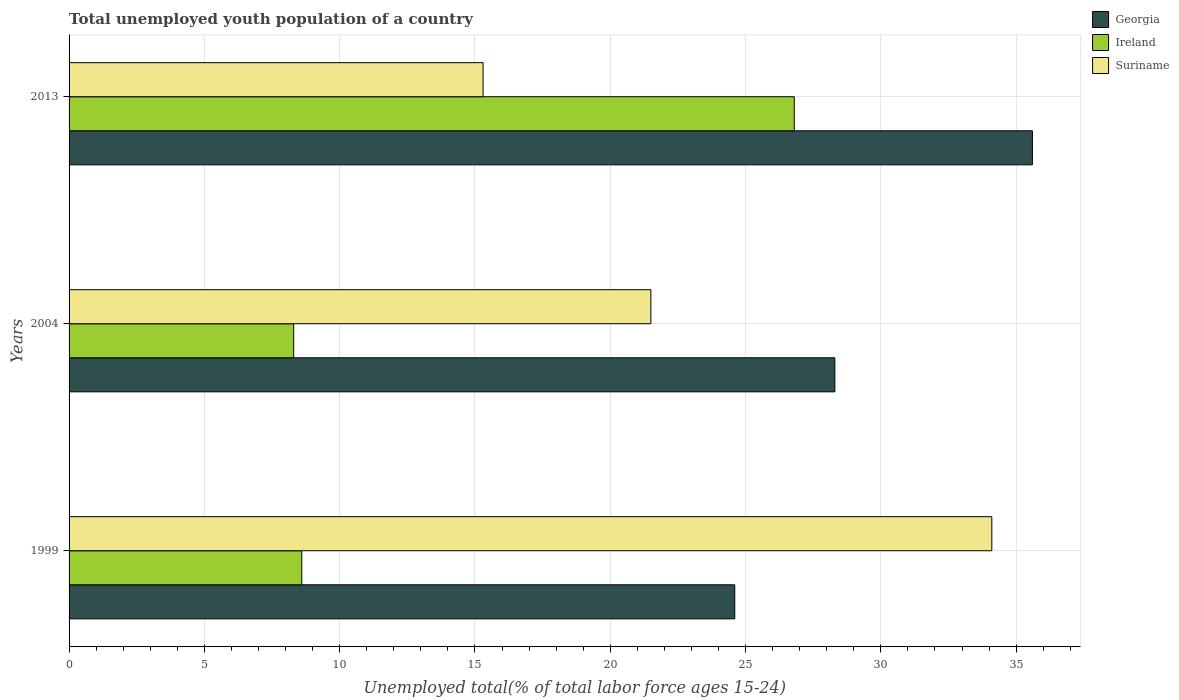How many different coloured bars are there?
Your response must be concise. 3. How many groups of bars are there?
Your response must be concise. 3. Are the number of bars per tick equal to the number of legend labels?
Give a very brief answer. Yes. Are the number of bars on each tick of the Y-axis equal?
Provide a short and direct response. Yes. What is the label of the 2nd group of bars from the top?
Offer a very short reply. 2004. Across all years, what is the maximum percentage of total unemployed youth population of a country in Ireland?
Make the answer very short. 26.8. Across all years, what is the minimum percentage of total unemployed youth population of a country in Suriname?
Your answer should be compact. 15.3. In which year was the percentage of total unemployed youth population of a country in Suriname maximum?
Keep it short and to the point. 1999. What is the total percentage of total unemployed youth population of a country in Suriname in the graph?
Your response must be concise. 70.9. What is the difference between the percentage of total unemployed youth population of a country in Ireland in 1999 and that in 2004?
Offer a terse response. 0.3. What is the difference between the percentage of total unemployed youth population of a country in Ireland in 2013 and the percentage of total unemployed youth population of a country in Suriname in 1999?
Your response must be concise. -7.3. What is the average percentage of total unemployed youth population of a country in Suriname per year?
Make the answer very short. 23.63. In the year 2013, what is the difference between the percentage of total unemployed youth population of a country in Ireland and percentage of total unemployed youth population of a country in Georgia?
Offer a terse response. -8.8. What is the ratio of the percentage of total unemployed youth population of a country in Georgia in 1999 to that in 2004?
Keep it short and to the point. 0.87. Is the percentage of total unemployed youth population of a country in Suriname in 1999 less than that in 2004?
Offer a terse response. No. Is the difference between the percentage of total unemployed youth population of a country in Ireland in 1999 and 2004 greater than the difference between the percentage of total unemployed youth population of a country in Georgia in 1999 and 2004?
Give a very brief answer. Yes. What is the difference between the highest and the second highest percentage of total unemployed youth population of a country in Suriname?
Make the answer very short. 12.6. What is the difference between the highest and the lowest percentage of total unemployed youth population of a country in Georgia?
Make the answer very short. 11. Is the sum of the percentage of total unemployed youth population of a country in Suriname in 1999 and 2013 greater than the maximum percentage of total unemployed youth population of a country in Ireland across all years?
Your answer should be compact. Yes. What does the 1st bar from the top in 1999 represents?
Keep it short and to the point. Suriname. What does the 1st bar from the bottom in 2013 represents?
Give a very brief answer. Georgia. Is it the case that in every year, the sum of the percentage of total unemployed youth population of a country in Georgia and percentage of total unemployed youth population of a country in Ireland is greater than the percentage of total unemployed youth population of a country in Suriname?
Make the answer very short. No. How many years are there in the graph?
Make the answer very short. 3. Are the values on the major ticks of X-axis written in scientific E-notation?
Make the answer very short. No. Where does the legend appear in the graph?
Your answer should be very brief. Top right. How are the legend labels stacked?
Keep it short and to the point. Vertical. What is the title of the graph?
Offer a terse response. Total unemployed youth population of a country. What is the label or title of the X-axis?
Give a very brief answer. Unemployed total(% of total labor force ages 15-24). What is the label or title of the Y-axis?
Provide a succinct answer. Years. What is the Unemployed total(% of total labor force ages 15-24) of Georgia in 1999?
Provide a succinct answer. 24.6. What is the Unemployed total(% of total labor force ages 15-24) in Ireland in 1999?
Provide a succinct answer. 8.6. What is the Unemployed total(% of total labor force ages 15-24) in Suriname in 1999?
Ensure brevity in your answer.  34.1. What is the Unemployed total(% of total labor force ages 15-24) in Georgia in 2004?
Offer a very short reply. 28.3. What is the Unemployed total(% of total labor force ages 15-24) in Ireland in 2004?
Ensure brevity in your answer.  8.3. What is the Unemployed total(% of total labor force ages 15-24) of Suriname in 2004?
Your answer should be compact. 21.5. What is the Unemployed total(% of total labor force ages 15-24) of Georgia in 2013?
Your answer should be very brief. 35.6. What is the Unemployed total(% of total labor force ages 15-24) in Ireland in 2013?
Your response must be concise. 26.8. What is the Unemployed total(% of total labor force ages 15-24) in Suriname in 2013?
Provide a short and direct response. 15.3. Across all years, what is the maximum Unemployed total(% of total labor force ages 15-24) of Georgia?
Provide a short and direct response. 35.6. Across all years, what is the maximum Unemployed total(% of total labor force ages 15-24) in Ireland?
Your answer should be compact. 26.8. Across all years, what is the maximum Unemployed total(% of total labor force ages 15-24) in Suriname?
Offer a terse response. 34.1. Across all years, what is the minimum Unemployed total(% of total labor force ages 15-24) in Georgia?
Ensure brevity in your answer.  24.6. Across all years, what is the minimum Unemployed total(% of total labor force ages 15-24) of Ireland?
Offer a very short reply. 8.3. Across all years, what is the minimum Unemployed total(% of total labor force ages 15-24) in Suriname?
Make the answer very short. 15.3. What is the total Unemployed total(% of total labor force ages 15-24) in Georgia in the graph?
Your answer should be compact. 88.5. What is the total Unemployed total(% of total labor force ages 15-24) in Ireland in the graph?
Provide a succinct answer. 43.7. What is the total Unemployed total(% of total labor force ages 15-24) in Suriname in the graph?
Offer a very short reply. 70.9. What is the difference between the Unemployed total(% of total labor force ages 15-24) of Georgia in 1999 and that in 2004?
Offer a very short reply. -3.7. What is the difference between the Unemployed total(% of total labor force ages 15-24) in Suriname in 1999 and that in 2004?
Make the answer very short. 12.6. What is the difference between the Unemployed total(% of total labor force ages 15-24) in Georgia in 1999 and that in 2013?
Keep it short and to the point. -11. What is the difference between the Unemployed total(% of total labor force ages 15-24) of Ireland in 1999 and that in 2013?
Offer a very short reply. -18.2. What is the difference between the Unemployed total(% of total labor force ages 15-24) of Georgia in 2004 and that in 2013?
Offer a terse response. -7.3. What is the difference between the Unemployed total(% of total labor force ages 15-24) of Ireland in 2004 and that in 2013?
Keep it short and to the point. -18.5. What is the difference between the Unemployed total(% of total labor force ages 15-24) in Georgia in 1999 and the Unemployed total(% of total labor force ages 15-24) in Ireland in 2004?
Give a very brief answer. 16.3. What is the difference between the Unemployed total(% of total labor force ages 15-24) of Georgia in 1999 and the Unemployed total(% of total labor force ages 15-24) of Suriname in 2004?
Make the answer very short. 3.1. What is the difference between the Unemployed total(% of total labor force ages 15-24) of Georgia in 1999 and the Unemployed total(% of total labor force ages 15-24) of Ireland in 2013?
Your answer should be very brief. -2.2. What is the difference between the Unemployed total(% of total labor force ages 15-24) of Georgia in 1999 and the Unemployed total(% of total labor force ages 15-24) of Suriname in 2013?
Keep it short and to the point. 9.3. What is the difference between the Unemployed total(% of total labor force ages 15-24) of Ireland in 1999 and the Unemployed total(% of total labor force ages 15-24) of Suriname in 2013?
Your response must be concise. -6.7. What is the difference between the Unemployed total(% of total labor force ages 15-24) in Georgia in 2004 and the Unemployed total(% of total labor force ages 15-24) in Suriname in 2013?
Your answer should be compact. 13. What is the difference between the Unemployed total(% of total labor force ages 15-24) in Ireland in 2004 and the Unemployed total(% of total labor force ages 15-24) in Suriname in 2013?
Your response must be concise. -7. What is the average Unemployed total(% of total labor force ages 15-24) in Georgia per year?
Provide a succinct answer. 29.5. What is the average Unemployed total(% of total labor force ages 15-24) of Ireland per year?
Offer a terse response. 14.57. What is the average Unemployed total(% of total labor force ages 15-24) in Suriname per year?
Ensure brevity in your answer.  23.63. In the year 1999, what is the difference between the Unemployed total(% of total labor force ages 15-24) of Ireland and Unemployed total(% of total labor force ages 15-24) of Suriname?
Provide a short and direct response. -25.5. In the year 2004, what is the difference between the Unemployed total(% of total labor force ages 15-24) of Georgia and Unemployed total(% of total labor force ages 15-24) of Ireland?
Provide a succinct answer. 20. In the year 2013, what is the difference between the Unemployed total(% of total labor force ages 15-24) of Georgia and Unemployed total(% of total labor force ages 15-24) of Ireland?
Offer a terse response. 8.8. In the year 2013, what is the difference between the Unemployed total(% of total labor force ages 15-24) in Georgia and Unemployed total(% of total labor force ages 15-24) in Suriname?
Your response must be concise. 20.3. In the year 2013, what is the difference between the Unemployed total(% of total labor force ages 15-24) of Ireland and Unemployed total(% of total labor force ages 15-24) of Suriname?
Your answer should be compact. 11.5. What is the ratio of the Unemployed total(% of total labor force ages 15-24) in Georgia in 1999 to that in 2004?
Your response must be concise. 0.87. What is the ratio of the Unemployed total(% of total labor force ages 15-24) in Ireland in 1999 to that in 2004?
Offer a very short reply. 1.04. What is the ratio of the Unemployed total(% of total labor force ages 15-24) of Suriname in 1999 to that in 2004?
Provide a short and direct response. 1.59. What is the ratio of the Unemployed total(% of total labor force ages 15-24) in Georgia in 1999 to that in 2013?
Offer a terse response. 0.69. What is the ratio of the Unemployed total(% of total labor force ages 15-24) in Ireland in 1999 to that in 2013?
Provide a short and direct response. 0.32. What is the ratio of the Unemployed total(% of total labor force ages 15-24) in Suriname in 1999 to that in 2013?
Keep it short and to the point. 2.23. What is the ratio of the Unemployed total(% of total labor force ages 15-24) of Georgia in 2004 to that in 2013?
Give a very brief answer. 0.79. What is the ratio of the Unemployed total(% of total labor force ages 15-24) of Ireland in 2004 to that in 2013?
Give a very brief answer. 0.31. What is the ratio of the Unemployed total(% of total labor force ages 15-24) in Suriname in 2004 to that in 2013?
Provide a succinct answer. 1.41. What is the difference between the highest and the second highest Unemployed total(% of total labor force ages 15-24) in Georgia?
Provide a succinct answer. 7.3. What is the difference between the highest and the lowest Unemployed total(% of total labor force ages 15-24) in Georgia?
Provide a succinct answer. 11. What is the difference between the highest and the lowest Unemployed total(% of total labor force ages 15-24) in Ireland?
Offer a terse response. 18.5. What is the difference between the highest and the lowest Unemployed total(% of total labor force ages 15-24) in Suriname?
Make the answer very short. 18.8. 